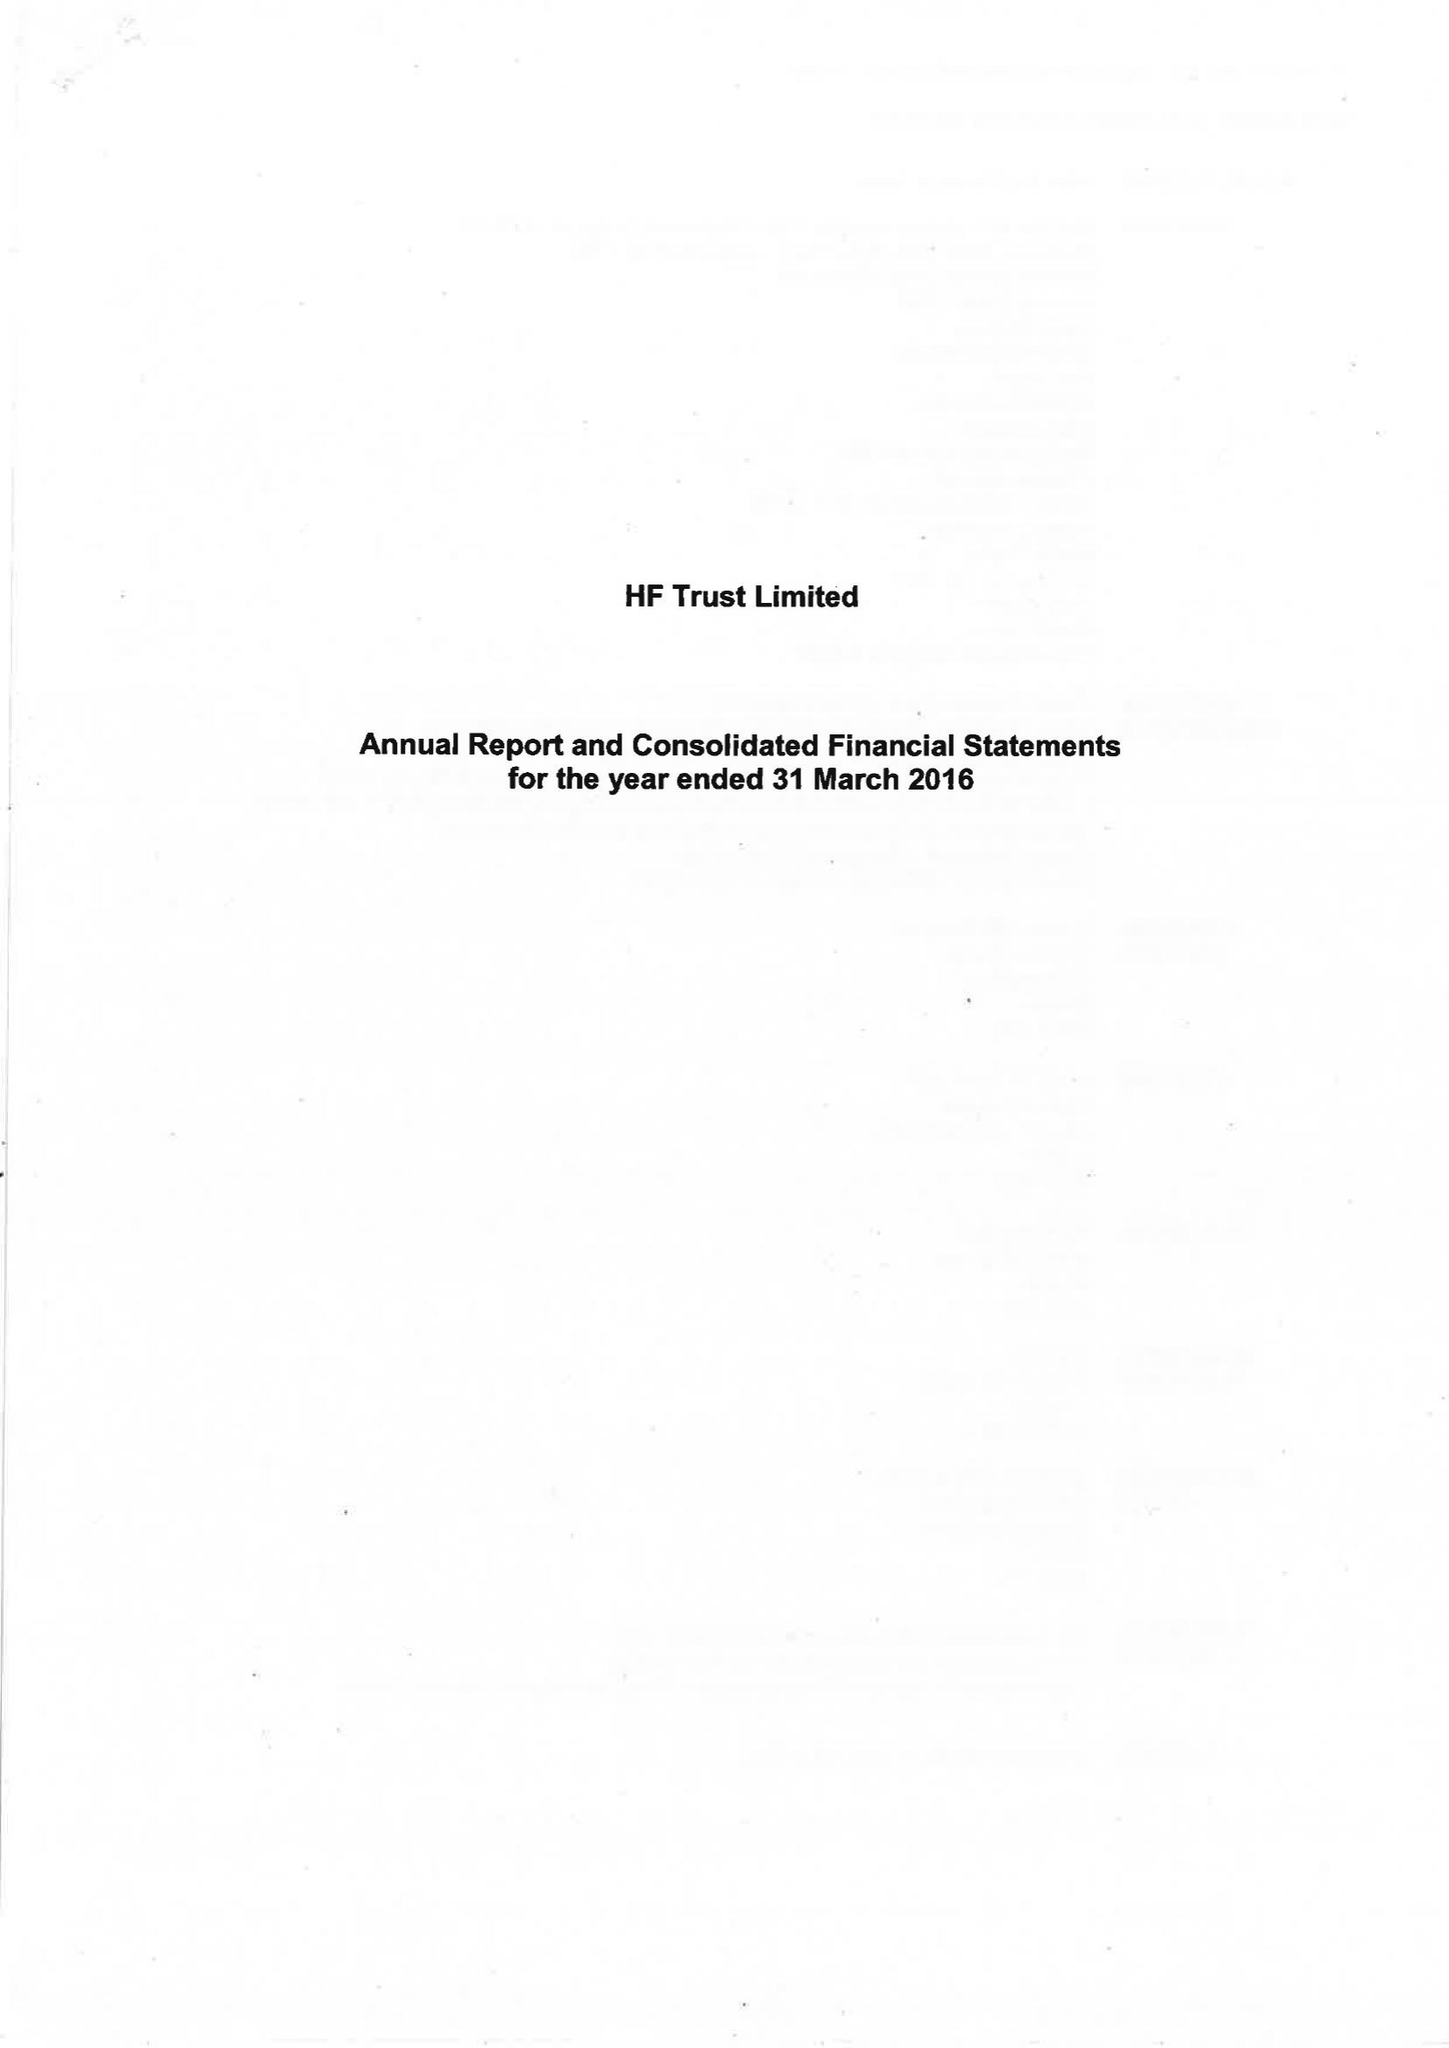What is the value for the spending_annually_in_british_pounds?
Answer the question using a single word or phrase. 73625000.00 